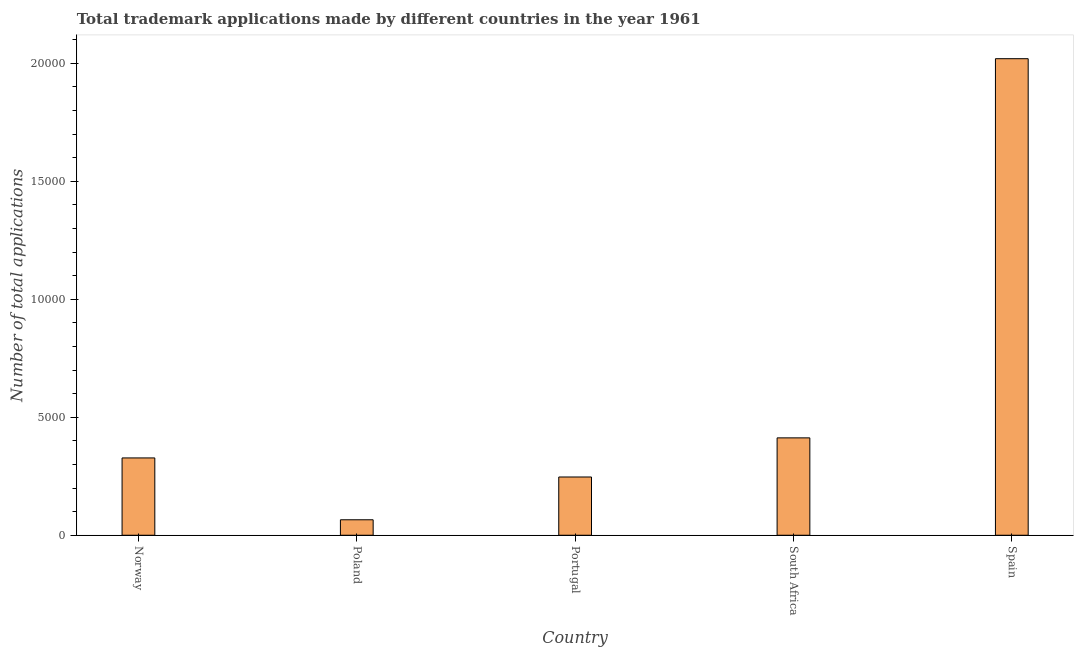Does the graph contain any zero values?
Provide a succinct answer. No. What is the title of the graph?
Your response must be concise. Total trademark applications made by different countries in the year 1961. What is the label or title of the Y-axis?
Provide a short and direct response. Number of total applications. What is the number of trademark applications in Poland?
Your answer should be compact. 655. Across all countries, what is the maximum number of trademark applications?
Offer a very short reply. 2.02e+04. Across all countries, what is the minimum number of trademark applications?
Offer a terse response. 655. In which country was the number of trademark applications maximum?
Your answer should be very brief. Spain. What is the sum of the number of trademark applications?
Your response must be concise. 3.07e+04. What is the difference between the number of trademark applications in Norway and Spain?
Your answer should be very brief. -1.69e+04. What is the average number of trademark applications per country?
Your answer should be compact. 6143. What is the median number of trademark applications?
Your answer should be compact. 3276. What is the ratio of the number of trademark applications in South Africa to that in Spain?
Your answer should be very brief. 0.2. Is the number of trademark applications in Norway less than that in South Africa?
Provide a succinct answer. Yes. Is the difference between the number of trademark applications in Portugal and Spain greater than the difference between any two countries?
Offer a very short reply. No. What is the difference between the highest and the second highest number of trademark applications?
Offer a very short reply. 1.61e+04. What is the difference between the highest and the lowest number of trademark applications?
Offer a terse response. 1.95e+04. Are the values on the major ticks of Y-axis written in scientific E-notation?
Keep it short and to the point. No. What is the Number of total applications in Norway?
Offer a terse response. 3276. What is the Number of total applications of Poland?
Make the answer very short. 655. What is the Number of total applications in Portugal?
Provide a short and direct response. 2468. What is the Number of total applications in South Africa?
Ensure brevity in your answer.  4126. What is the Number of total applications of Spain?
Your response must be concise. 2.02e+04. What is the difference between the Number of total applications in Norway and Poland?
Keep it short and to the point. 2621. What is the difference between the Number of total applications in Norway and Portugal?
Your answer should be compact. 808. What is the difference between the Number of total applications in Norway and South Africa?
Give a very brief answer. -850. What is the difference between the Number of total applications in Norway and Spain?
Your response must be concise. -1.69e+04. What is the difference between the Number of total applications in Poland and Portugal?
Keep it short and to the point. -1813. What is the difference between the Number of total applications in Poland and South Africa?
Your answer should be very brief. -3471. What is the difference between the Number of total applications in Poland and Spain?
Provide a short and direct response. -1.95e+04. What is the difference between the Number of total applications in Portugal and South Africa?
Offer a very short reply. -1658. What is the difference between the Number of total applications in Portugal and Spain?
Offer a terse response. -1.77e+04. What is the difference between the Number of total applications in South Africa and Spain?
Provide a short and direct response. -1.61e+04. What is the ratio of the Number of total applications in Norway to that in Poland?
Your answer should be compact. 5. What is the ratio of the Number of total applications in Norway to that in Portugal?
Your response must be concise. 1.33. What is the ratio of the Number of total applications in Norway to that in South Africa?
Give a very brief answer. 0.79. What is the ratio of the Number of total applications in Norway to that in Spain?
Give a very brief answer. 0.16. What is the ratio of the Number of total applications in Poland to that in Portugal?
Your response must be concise. 0.27. What is the ratio of the Number of total applications in Poland to that in South Africa?
Your response must be concise. 0.16. What is the ratio of the Number of total applications in Poland to that in Spain?
Ensure brevity in your answer.  0.03. What is the ratio of the Number of total applications in Portugal to that in South Africa?
Provide a short and direct response. 0.6. What is the ratio of the Number of total applications in Portugal to that in Spain?
Your answer should be very brief. 0.12. What is the ratio of the Number of total applications in South Africa to that in Spain?
Ensure brevity in your answer.  0.2. 